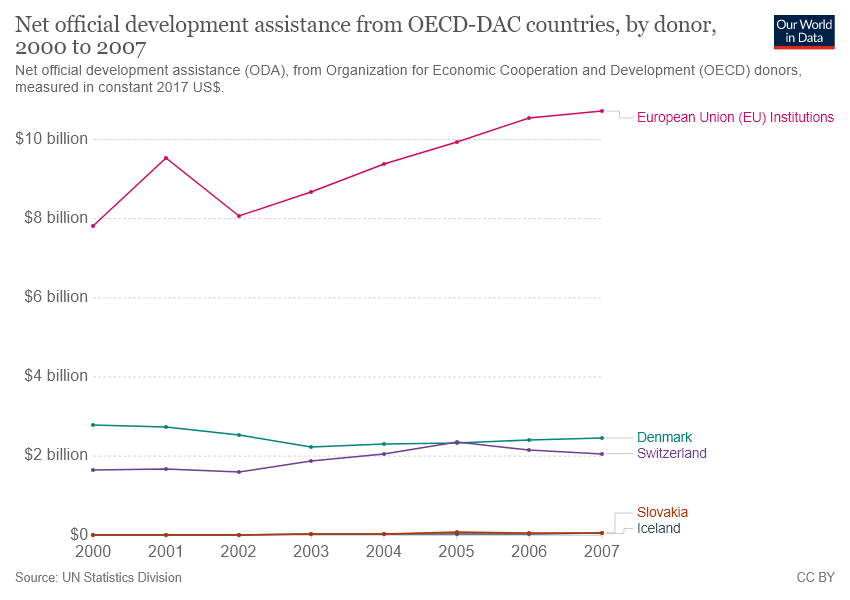Are there any noticeable differences in ODA contributions between Denmark and Switzerland? Yes, there is a slight difference in ODA contributions between Denmark and Switzerland as illustrated in the graph. Denmark consistently appears to contribute slightly more ODA than Switzerland from 2000 to 2007. However, both countries show relatively stable trends in their ODA figures over these years, with their combined contributions ranging between roughly $2 billion and $3 billion annually. 